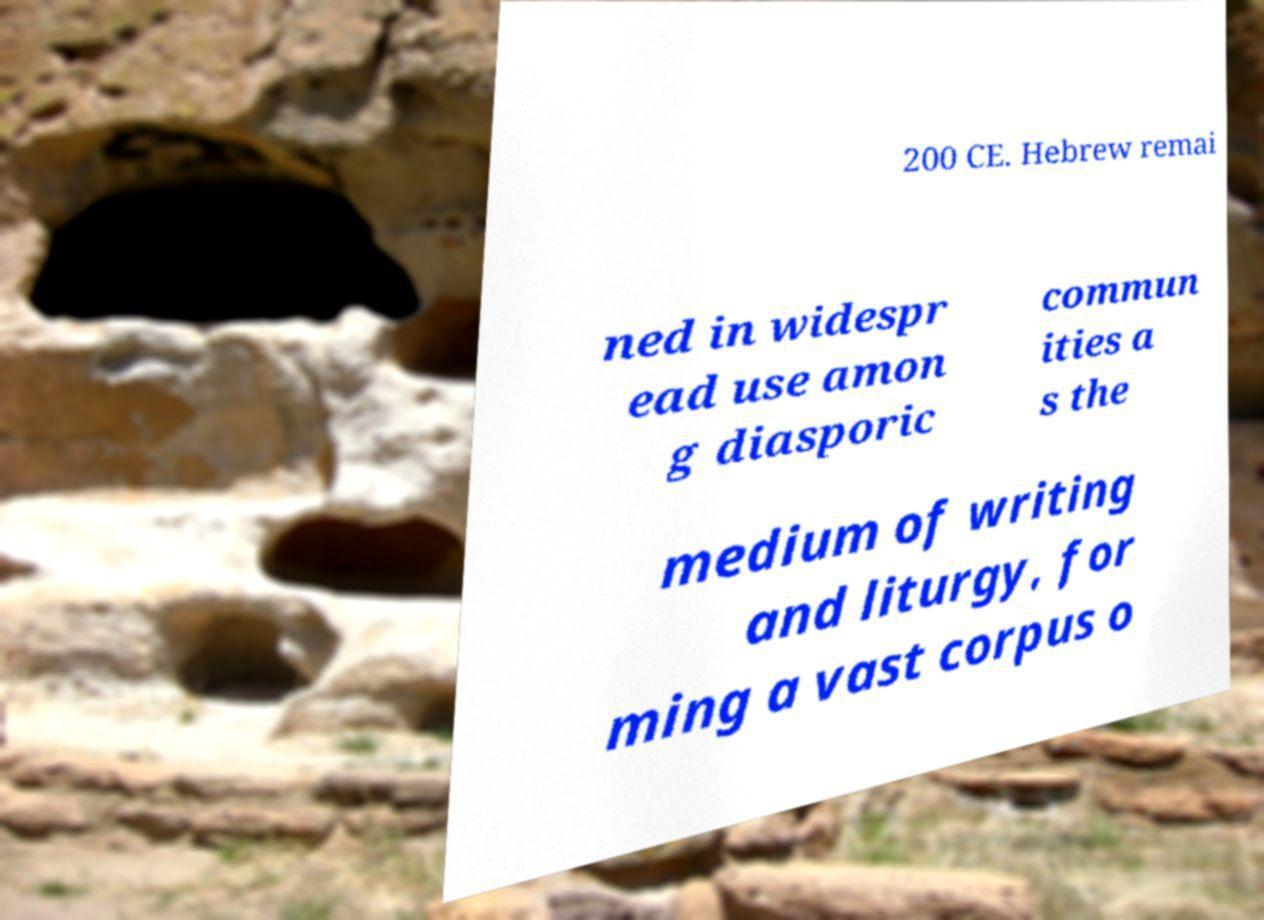I need the written content from this picture converted into text. Can you do that? 200 CE. Hebrew remai ned in widespr ead use amon g diasporic commun ities a s the medium of writing and liturgy, for ming a vast corpus o 